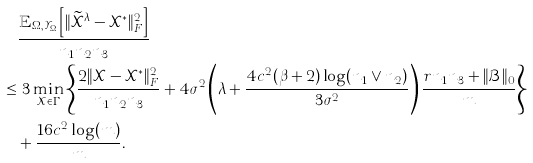<formula> <loc_0><loc_0><loc_500><loc_500>& \frac { \mathbb { E } _ { \Omega , \mathcal { Y } _ { \Omega } } \left [ \| \widetilde { \mathcal { X } } ^ { \lambda } - \mathcal { X } ^ { * } \| _ { F } ^ { 2 } \right ] } { n _ { 1 } n _ { 2 } n _ { 3 } } \\ \leq & \ 3 \min _ { \mathcal { X } \in \Gamma } \left \{ \frac { 2 \| \mathcal { X } - \mathcal { X } ^ { * } \| _ { F } ^ { 2 } } { n _ { 1 } n _ { 2 } n _ { 3 } } + 4 \sigma ^ { 2 } \left ( \lambda + \frac { 4 c ^ { 2 } ( \beta + 2 ) \log ( n _ { 1 } \vee n _ { 2 } ) } { 3 \sigma ^ { 2 } } \right ) \frac { r n _ { 1 } n _ { 3 } + \| \mathcal { B } \| _ { 0 } } { m } \right \} \\ & + \frac { 1 6 c ^ { 2 } \log ( m ) } { m } .</formula> 